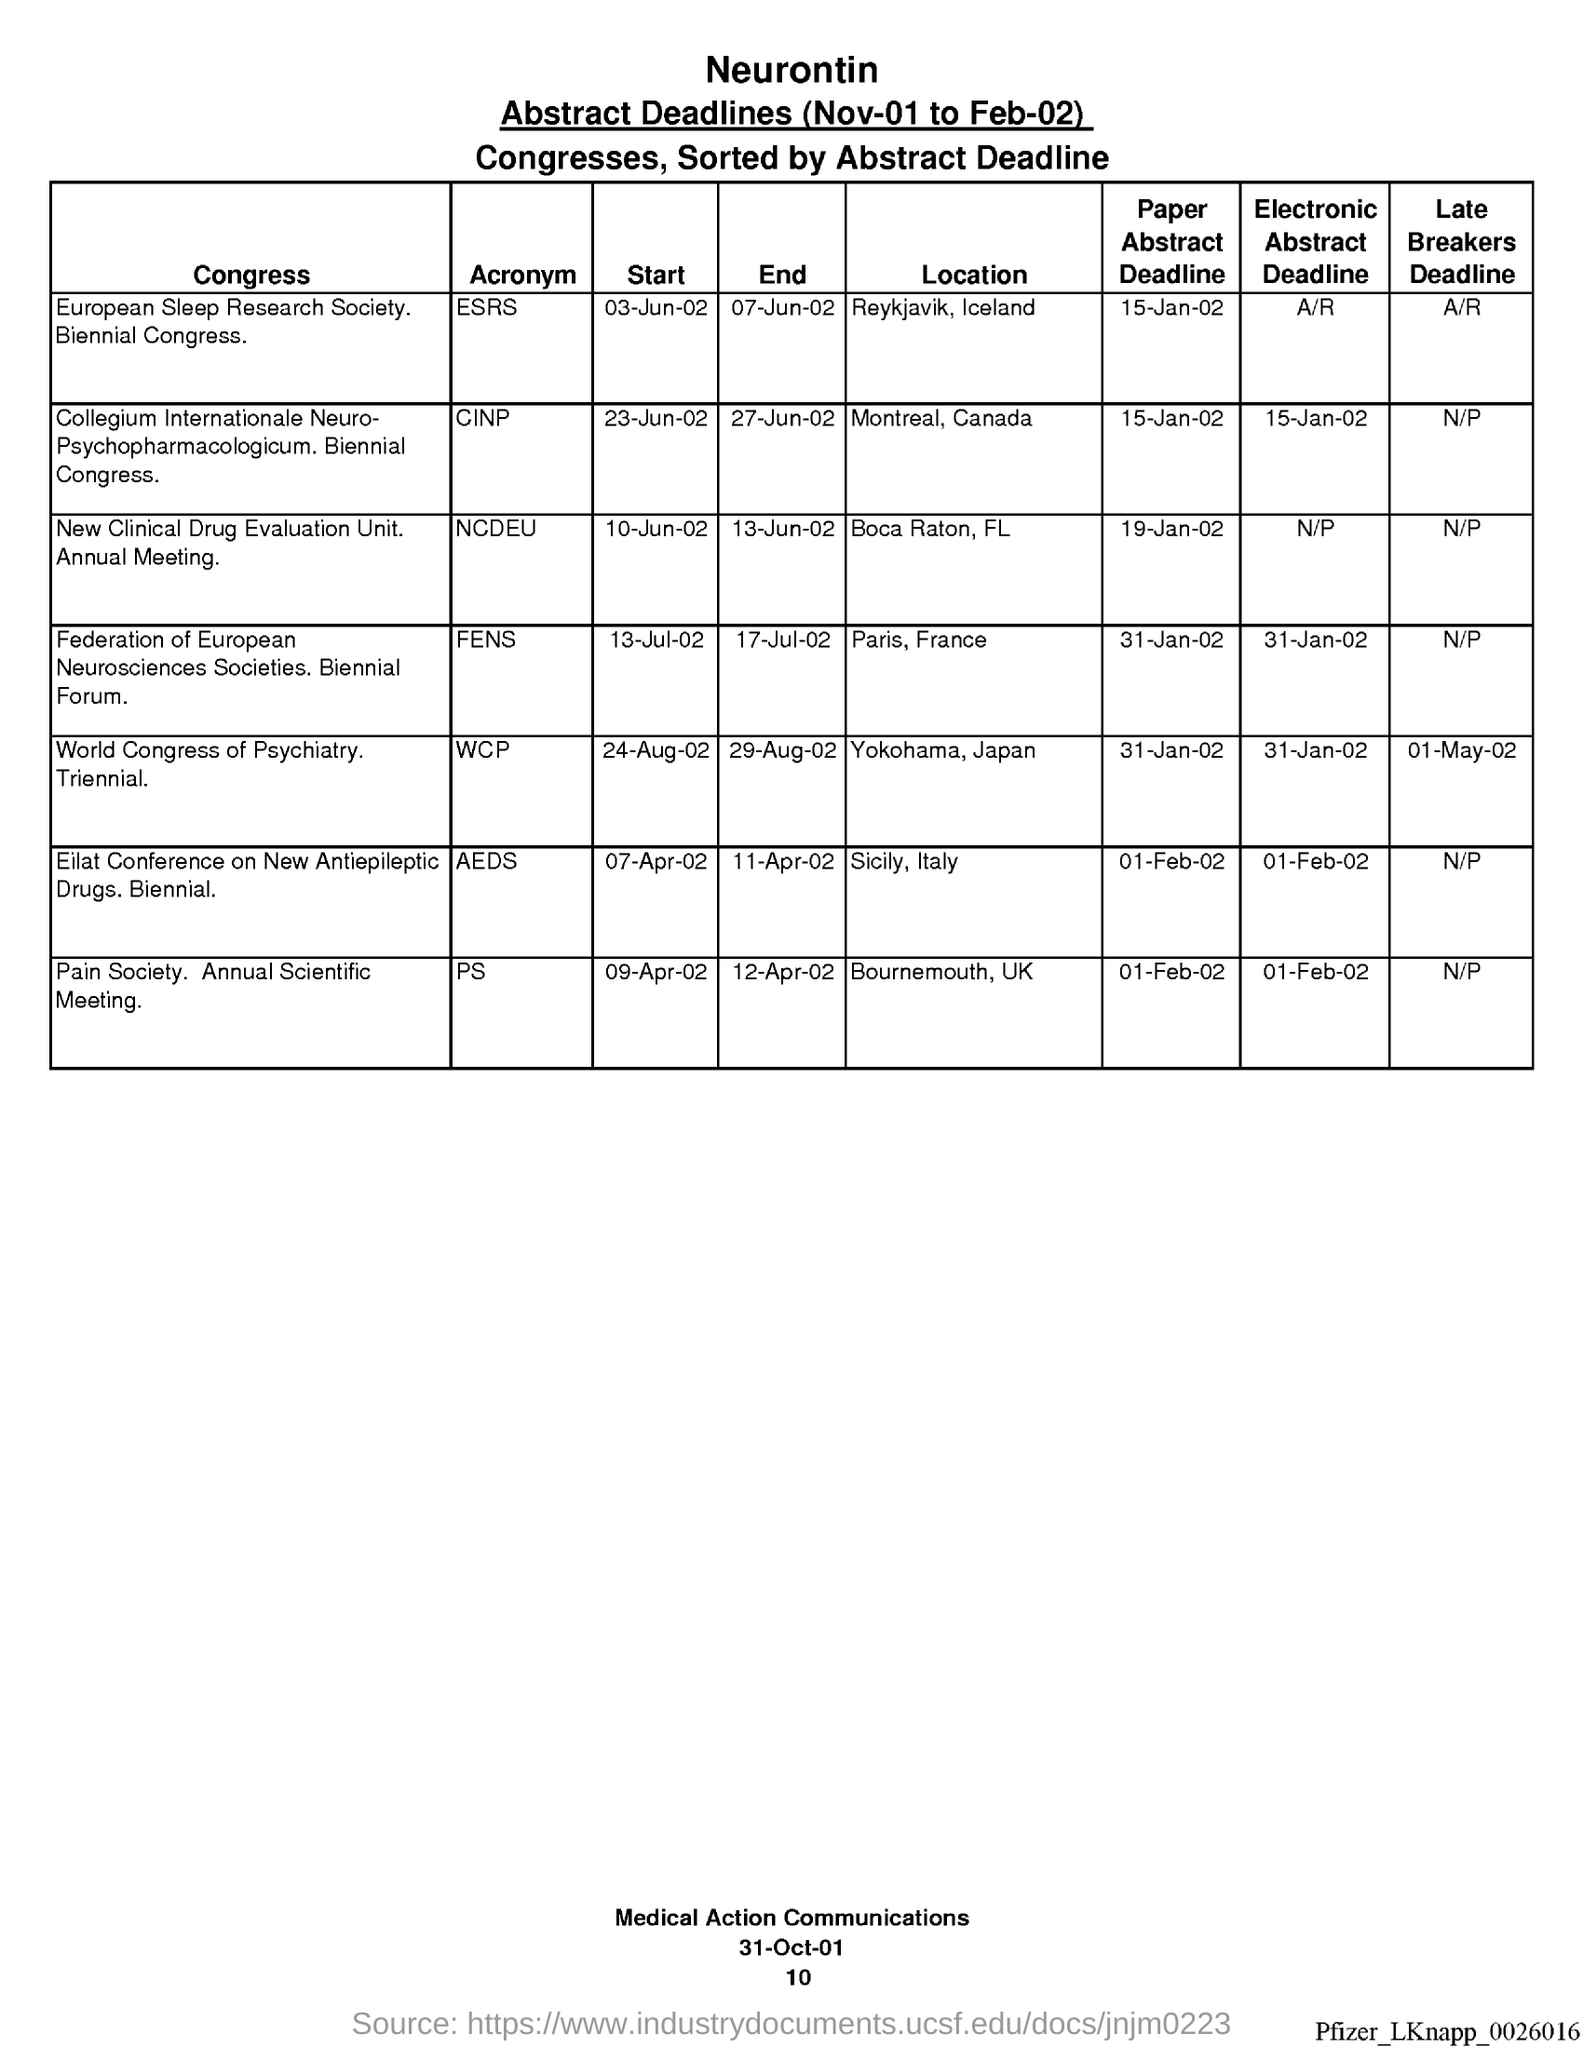What is the Location for ESRS?
Make the answer very short. Reykjavik, Iceland. What is the Location for CINP?
Provide a succinct answer. Montreal, Canada. What is the Location for NCDEU?
Provide a succinct answer. Boca Raton, FL. What is the Location for FENS?
Your response must be concise. Paris, France. What is the Location for WCP?
Give a very brief answer. Yokohama, Japan. What is the Location for AEDS?
Provide a succinct answer. Sicily, Italy. What is the Location for PS?
Your answer should be compact. Bournemouth, UK. What is the Paper Abstract Deadline for ESRS?
Give a very brief answer. 15-Jan-02. What is the Paper Abstract Deadline for CINP?
Your answer should be compact. 15-Jan-02. What is the Paper Abstract Deadline for NCDEU?
Provide a short and direct response. 19-Jan-02. 